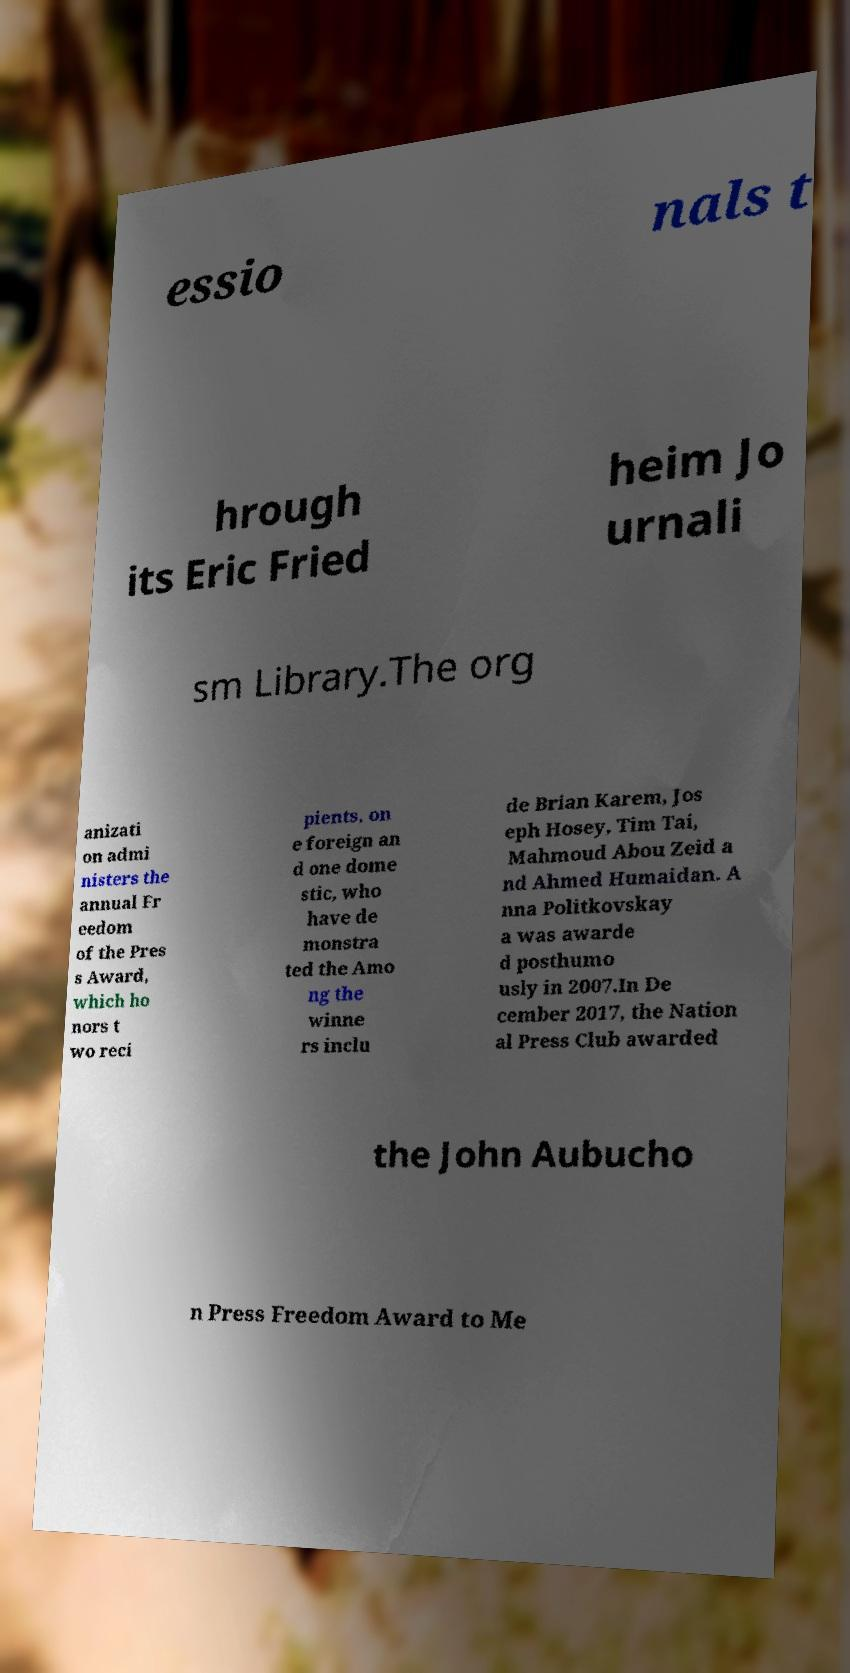What messages or text are displayed in this image? I need them in a readable, typed format. essio nals t hrough its Eric Fried heim Jo urnali sm Library.The org anizati on admi nisters the annual Fr eedom of the Pres s Award, which ho nors t wo reci pients, on e foreign an d one dome stic, who have de monstra ted the Amo ng the winne rs inclu de Brian Karem, Jos eph Hosey, Tim Tai, Mahmoud Abou Zeid a nd Ahmed Humaidan. A nna Politkovskay a was awarde d posthumo usly in 2007.In De cember 2017, the Nation al Press Club awarded the John Aubucho n Press Freedom Award to Me 